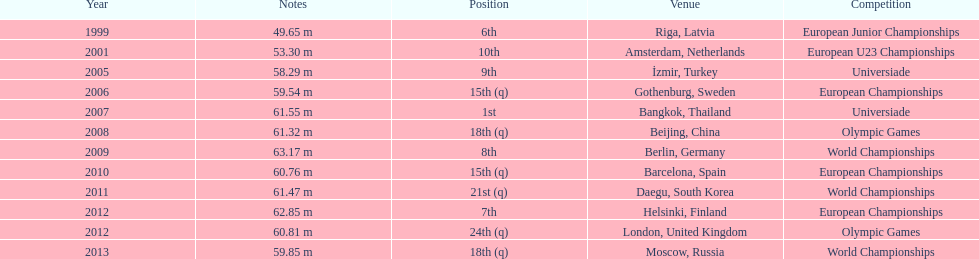Prior to 2007, what was the highest place achieved? 6th. 